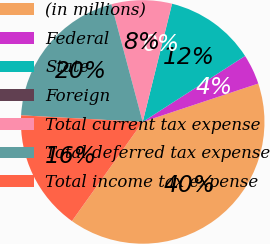Convert chart. <chart><loc_0><loc_0><loc_500><loc_500><pie_chart><fcel>(in millions)<fcel>Federal<fcel>State<fcel>Foreign<fcel>Total current tax expense<fcel>Total deferred tax expense<fcel>Total income tax expense<nl><fcel>39.96%<fcel>4.01%<fcel>12.0%<fcel>0.02%<fcel>8.01%<fcel>19.99%<fcel>16.0%<nl></chart> 